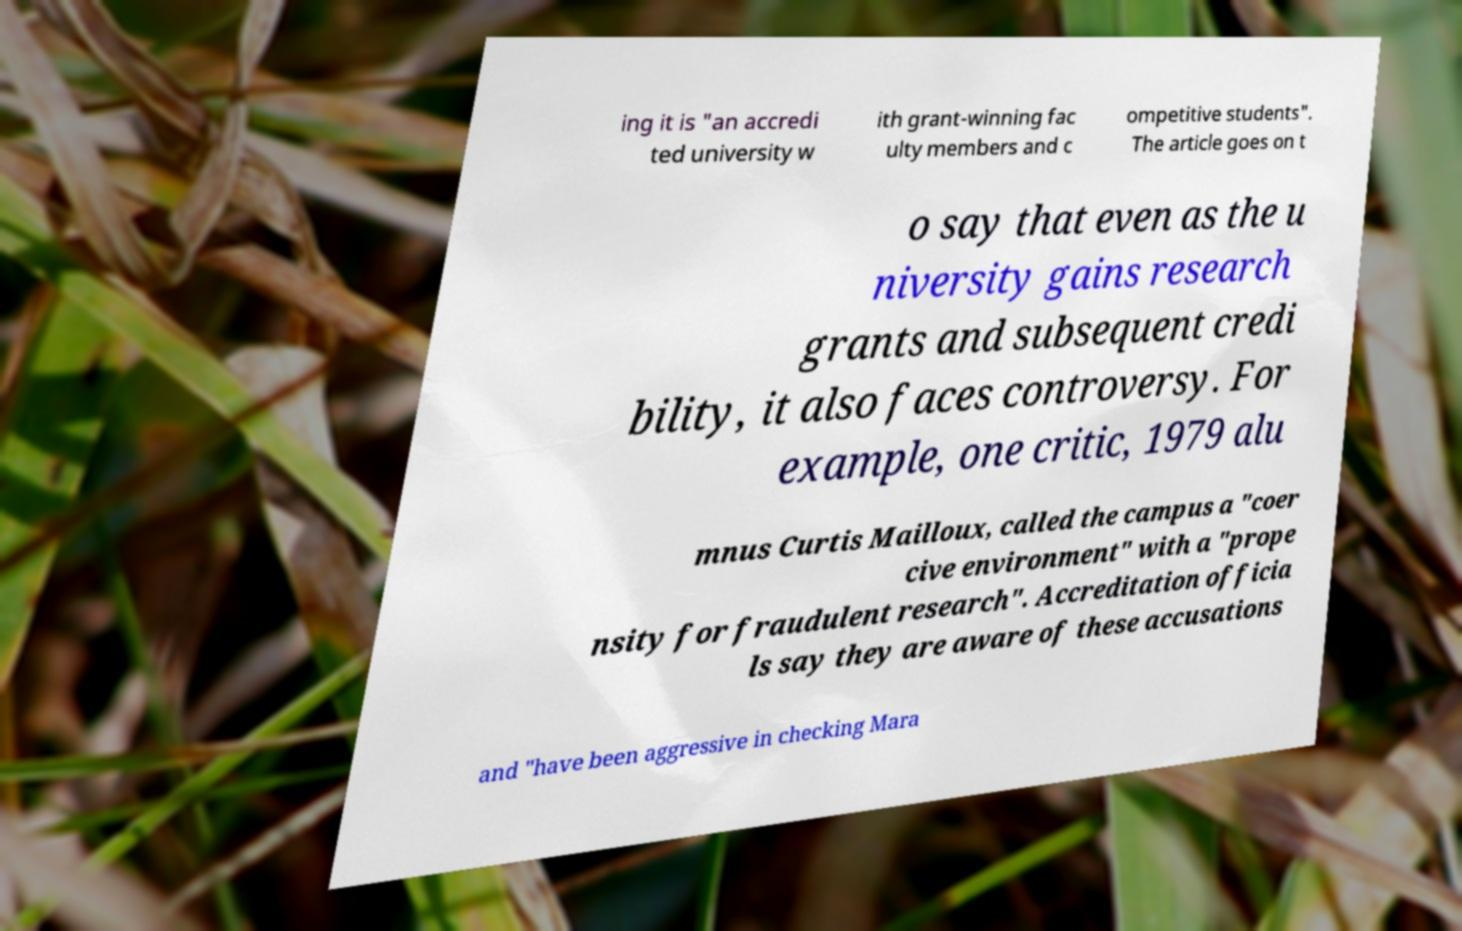Please identify and transcribe the text found in this image. ing it is "an accredi ted university w ith grant-winning fac ulty members and c ompetitive students". The article goes on t o say that even as the u niversity gains research grants and subsequent credi bility, it also faces controversy. For example, one critic, 1979 alu mnus Curtis Mailloux, called the campus a "coer cive environment" with a "prope nsity for fraudulent research". Accreditation officia ls say they are aware of these accusations and "have been aggressive in checking Mara 